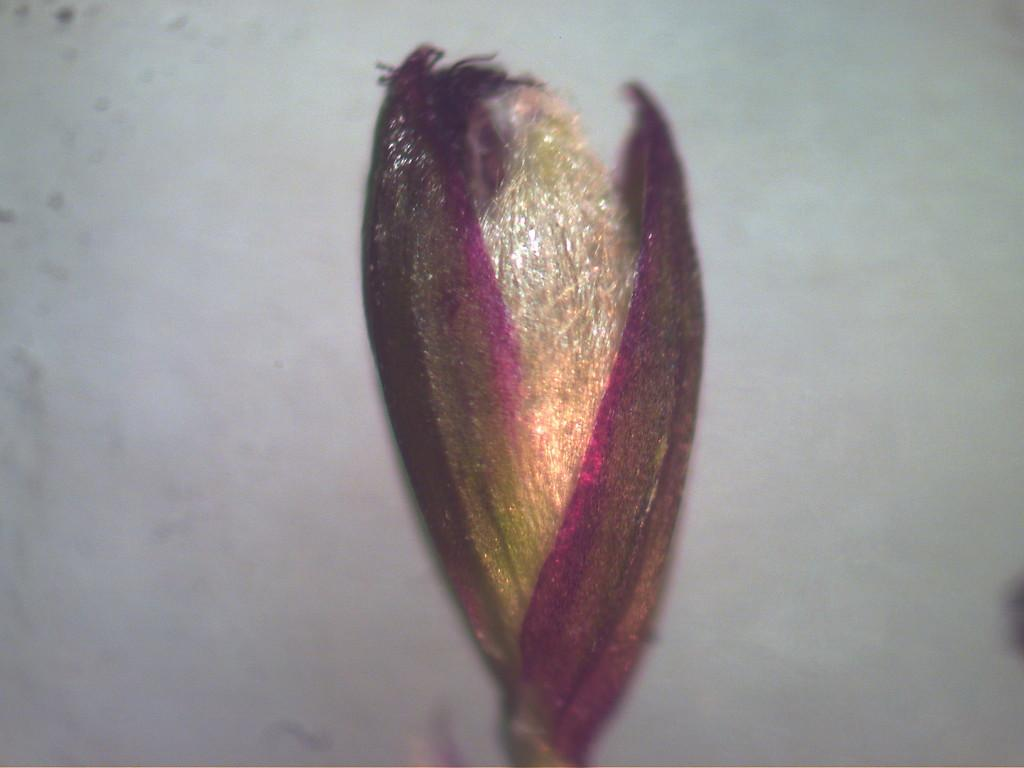What is the main subject of the image? The main subject of the image is a flower bud. Where is the flower bud located in the image? The flower bud is in the center of the image. What can be seen in the background of the image? There is a wall in the background of the image. How many bikes are parked next to the flower bud in the image? There are no bikes present in the image; it only features a flower bud and a wall in the background. 